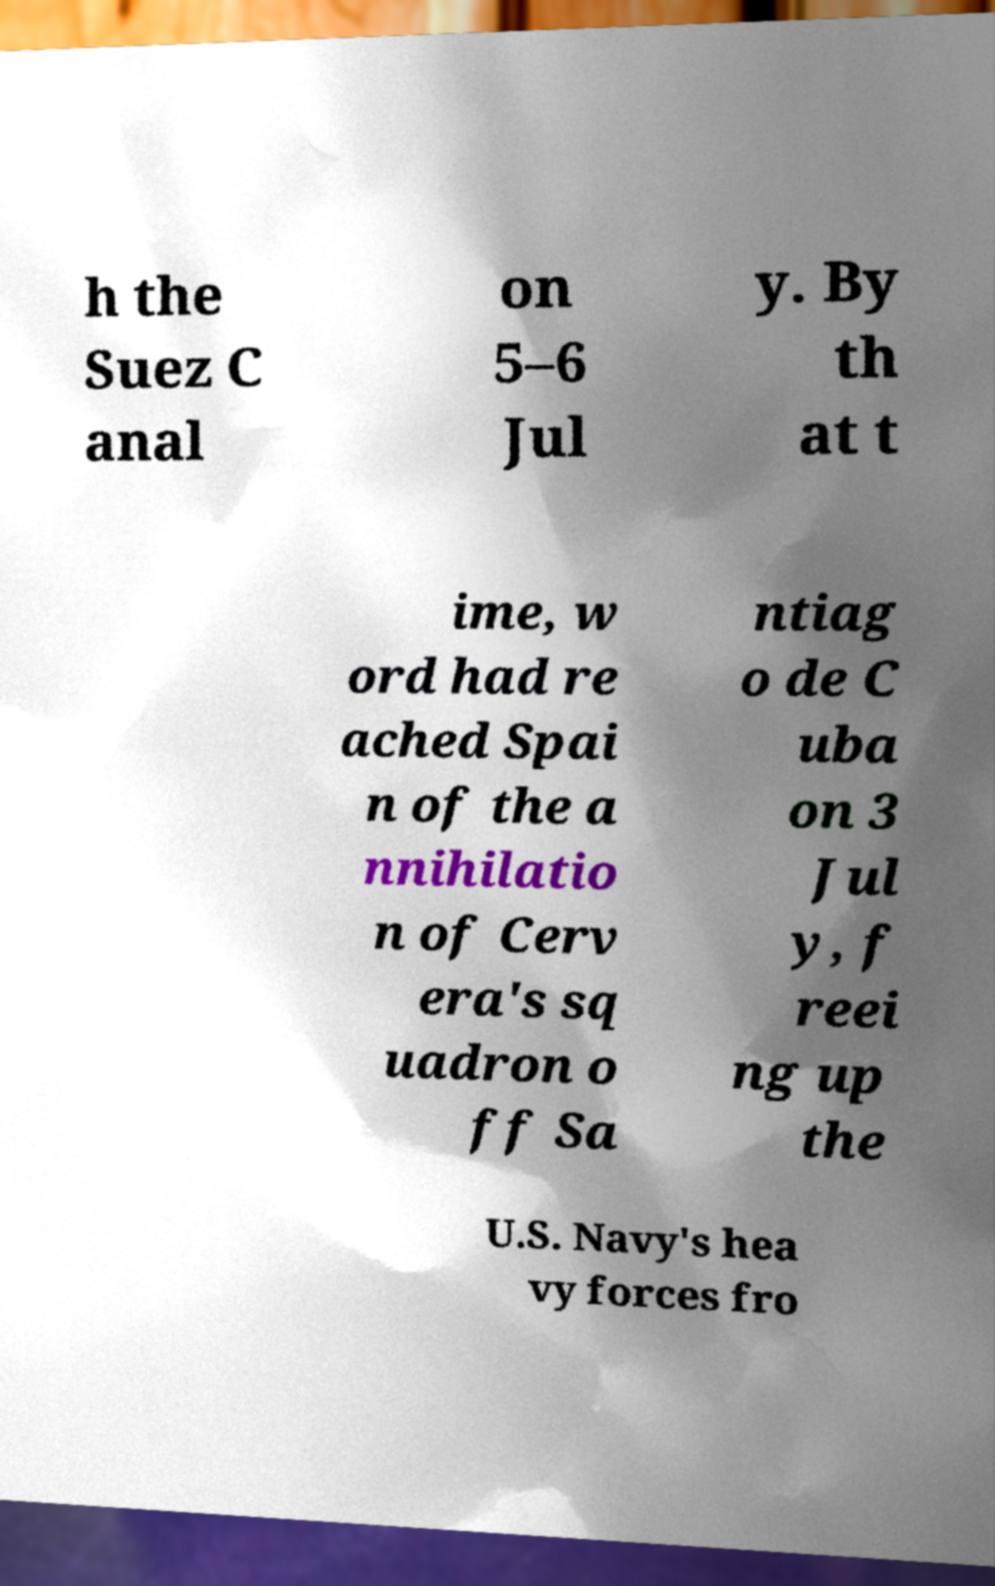Could you extract and type out the text from this image? h the Suez C anal on 5–6 Jul y. By th at t ime, w ord had re ached Spai n of the a nnihilatio n of Cerv era's sq uadron o ff Sa ntiag o de C uba on 3 Jul y, f reei ng up the U.S. Navy's hea vy forces fro 